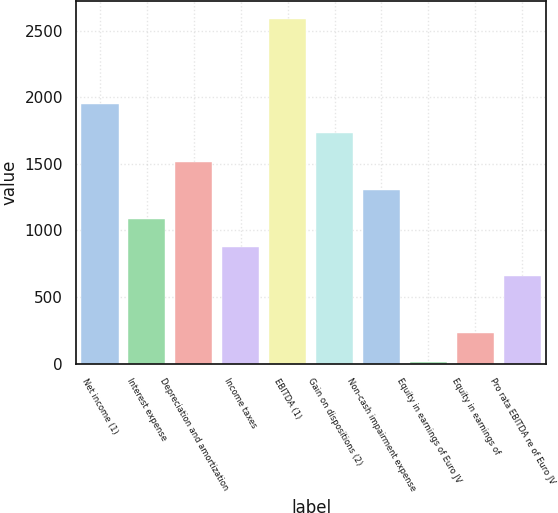Convert chart. <chart><loc_0><loc_0><loc_500><loc_500><bar_chart><fcel>Net income (1)<fcel>Interest expense<fcel>Depreciation and amortization<fcel>Income taxes<fcel>EBITDA (1)<fcel>Gain on dispositions (2)<fcel>Non-cash impairment expense<fcel>Equity in earnings of Euro JV<fcel>Equity in earnings of<fcel>Pro rata EBITDA re of Euro JV<nl><fcel>1946.3<fcel>1087.5<fcel>1516.9<fcel>872.8<fcel>2590.4<fcel>1731.6<fcel>1302.2<fcel>14<fcel>228.7<fcel>658.1<nl></chart> 